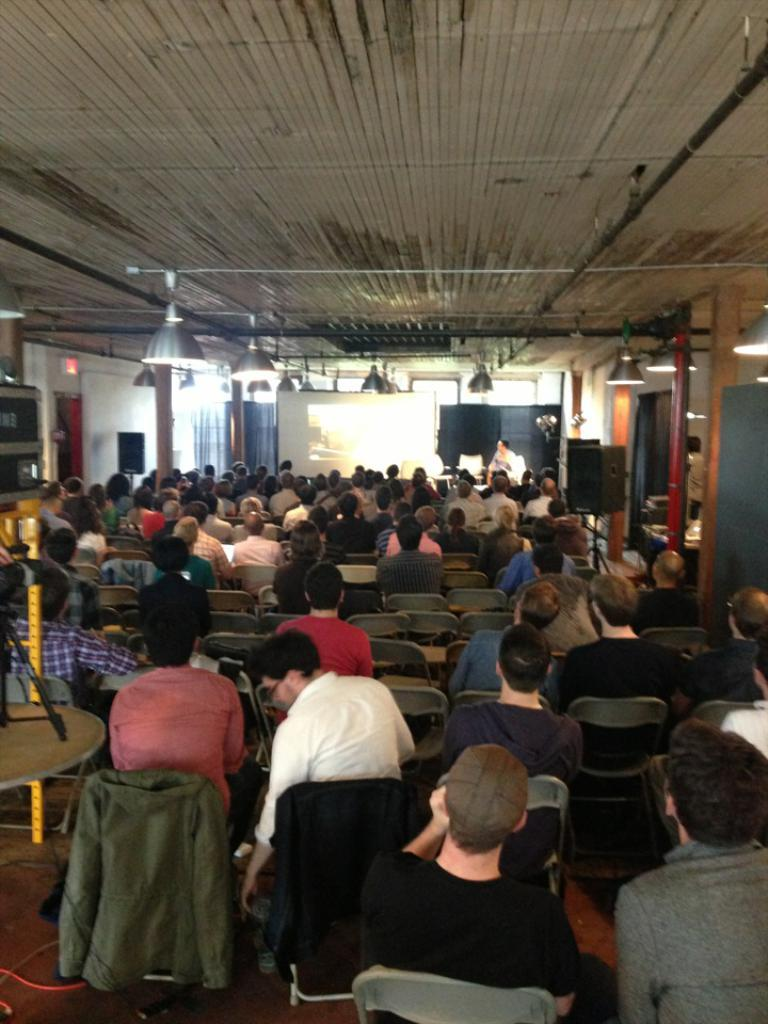How many people are in the image? There is a group of people in the image. What are the people doing in the image? The people are sitting on chairs. What can be seen in the image besides the people? There are speakers, pillars, lights, a screen, and windows in the image. What type of cabbage is being used as a boundary in the image? There is no cabbage present in the image, nor is there any boundary mentioned. 